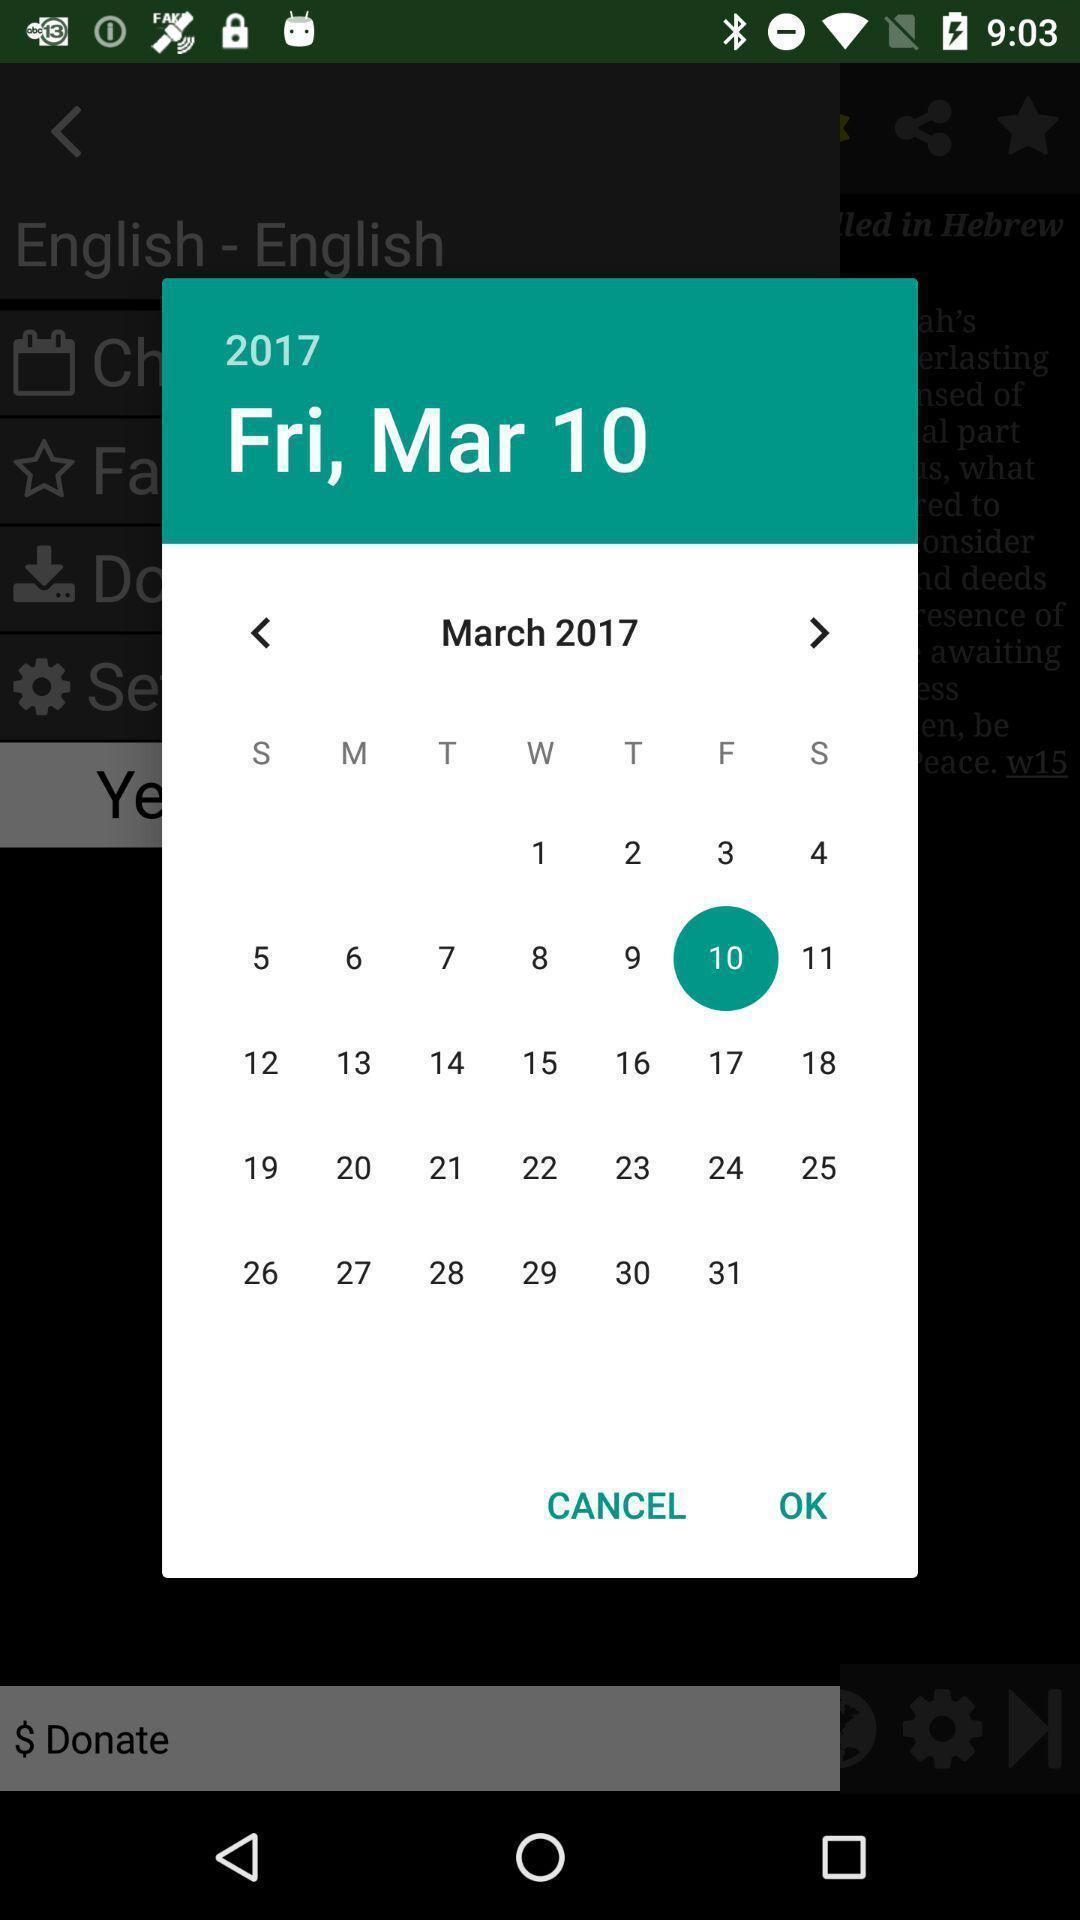Describe the visual elements of this screenshot. Pop up page for selecting a day in calendar. 